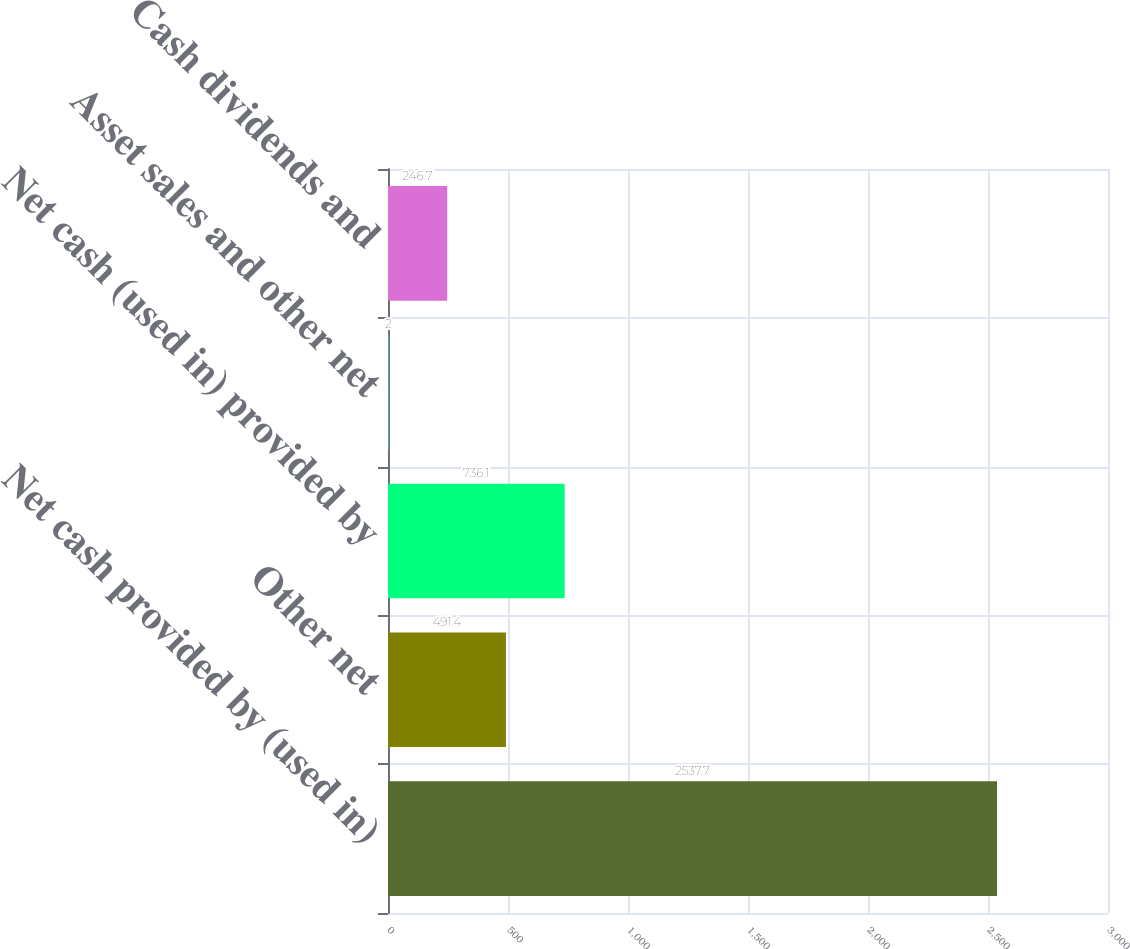Convert chart to OTSL. <chart><loc_0><loc_0><loc_500><loc_500><bar_chart><fcel>Net cash provided by (used in)<fcel>Other net<fcel>Net cash (used in) provided by<fcel>Asset sales and other net<fcel>Cash dividends and<nl><fcel>2537.7<fcel>491.4<fcel>736.1<fcel>2<fcel>246.7<nl></chart> 